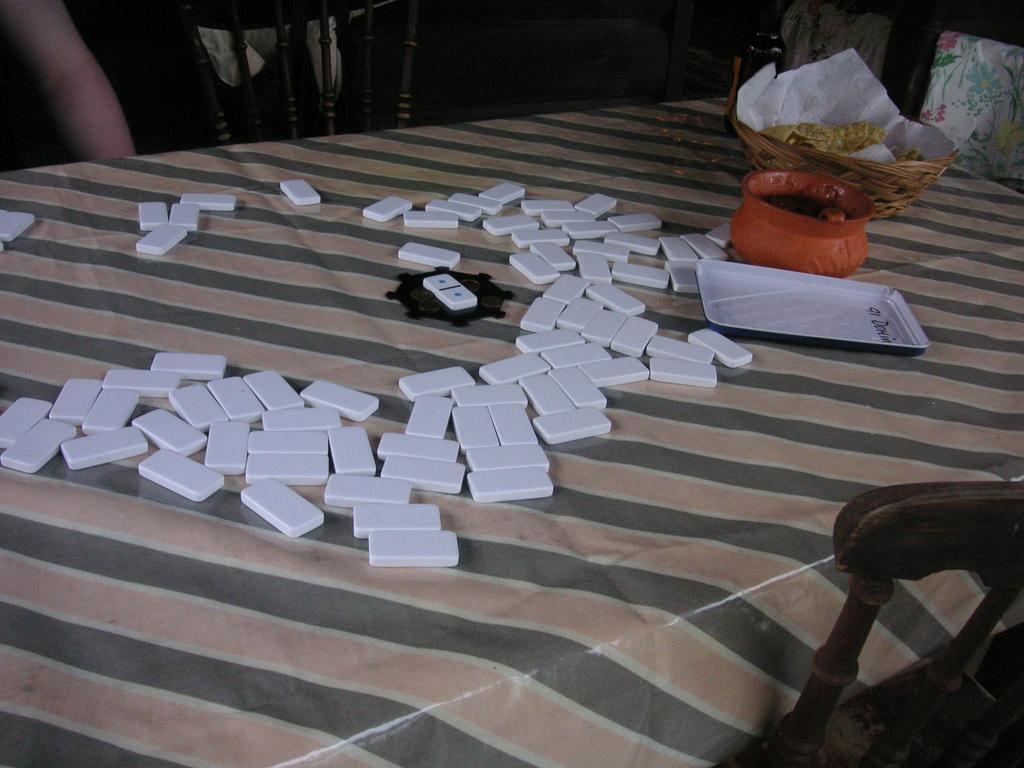Please provide a concise description of this image. In this image we can see a table. On the table there are white color pieces, tray, bowl and a basket with tissue and food item. Also there are chairs. At the top we can see hand of a person. 